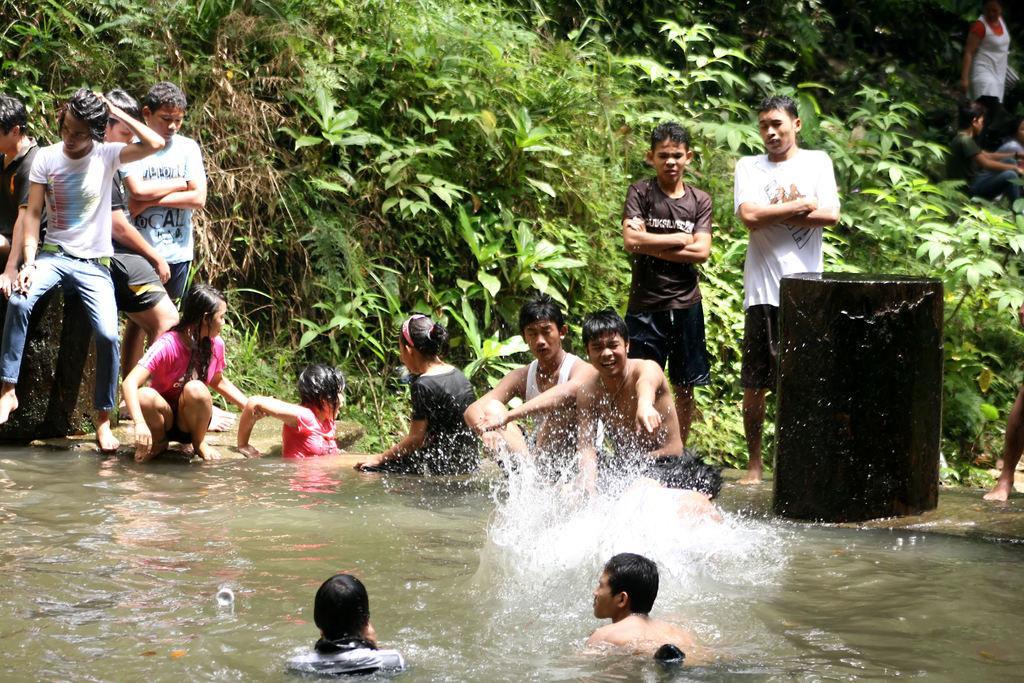Describe this image in one or two sentences. In the foreground of this image, there are two persons in the water. In the background, few are in the water, some of them are sitting and some of them are standing. We can also see trees and a drum in the background. 